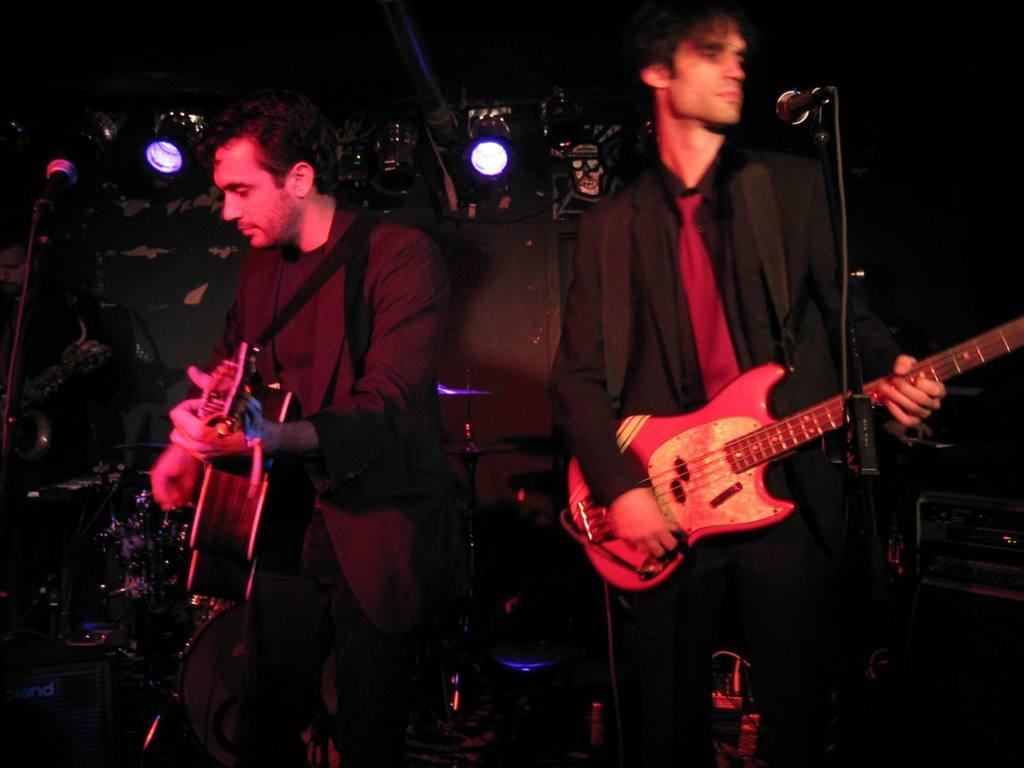How many people are in the image? There are two persons in the image. What are the two persons doing in the image? The two persons are standing in front of a microphone and playing guitar. What can be seen in the background of the image? There are lights visible in the image. What type of farm animals can be seen in the image? There are no farm animals present in the image. How many bushes are visible in the image? There is no mention of bushes in the provided facts, so it cannot be determined from the image. 